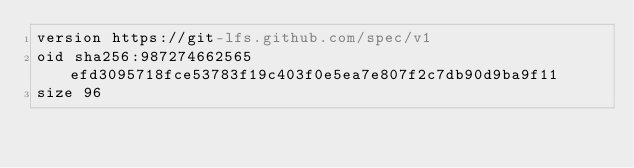Convert code to text. <code><loc_0><loc_0><loc_500><loc_500><_YAML_>version https://git-lfs.github.com/spec/v1
oid sha256:987274662565efd3095718fce53783f19c403f0e5ea7e807f2c7db90d9ba9f11
size 96
</code> 